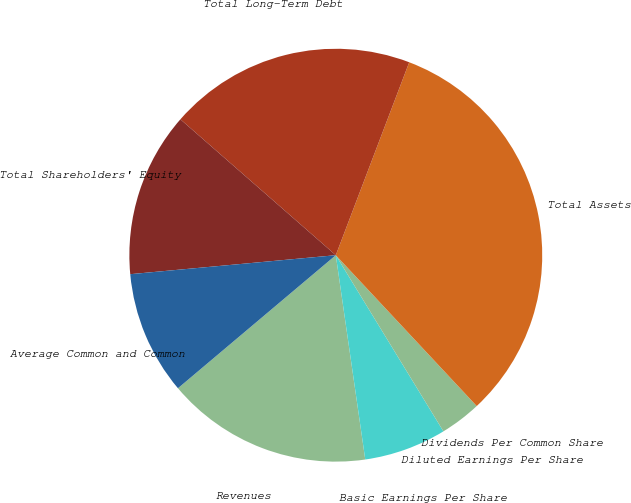<chart> <loc_0><loc_0><loc_500><loc_500><pie_chart><fcel>Revenues<fcel>Basic Earnings Per Share<fcel>Diluted Earnings Per Share<fcel>Dividends Per Common Share<fcel>Total Assets<fcel>Total Long-Term Debt<fcel>Total Shareholders' Equity<fcel>Average Common and Common<nl><fcel>16.13%<fcel>6.45%<fcel>3.23%<fcel>0.0%<fcel>32.25%<fcel>19.35%<fcel>12.9%<fcel>9.68%<nl></chart> 